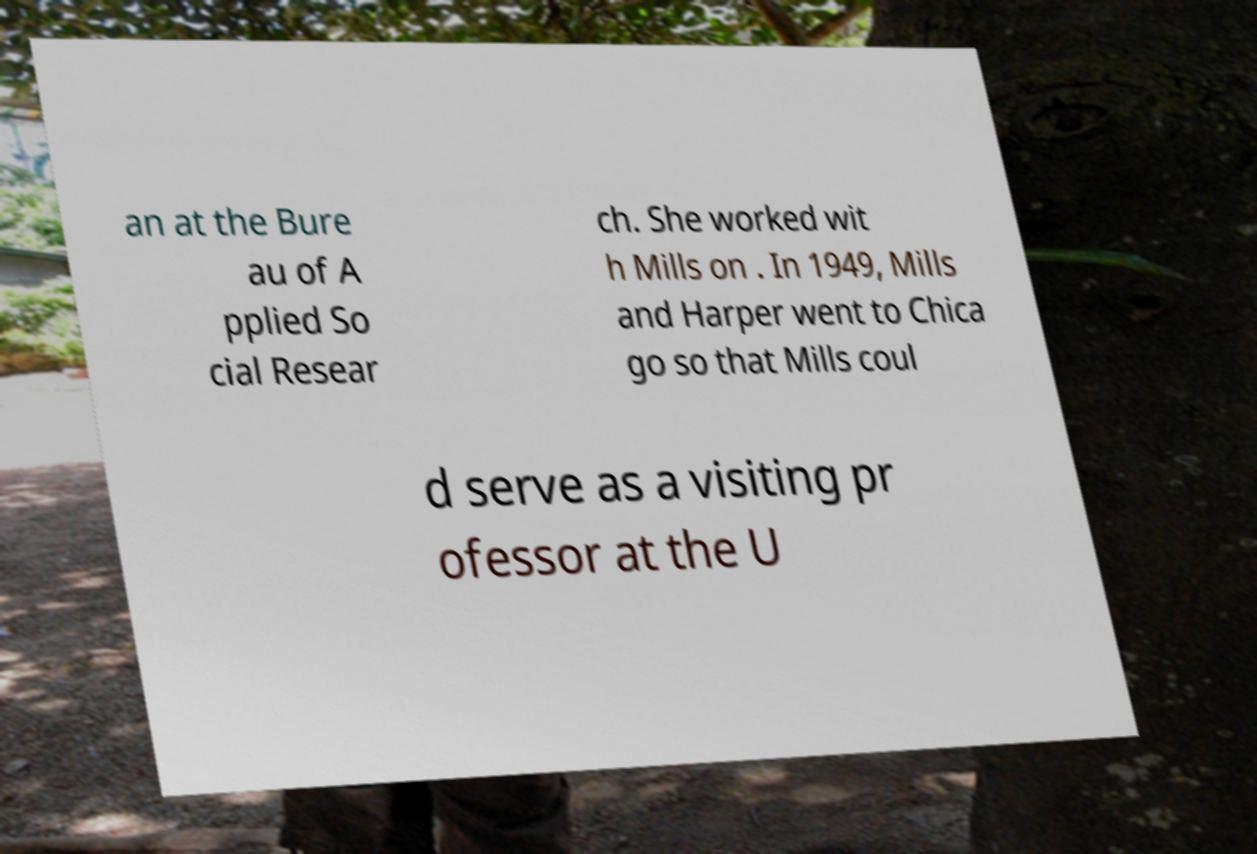What messages or text are displayed in this image? I need them in a readable, typed format. an at the Bure au of A pplied So cial Resear ch. She worked wit h Mills on . In 1949, Mills and Harper went to Chica go so that Mills coul d serve as a visiting pr ofessor at the U 